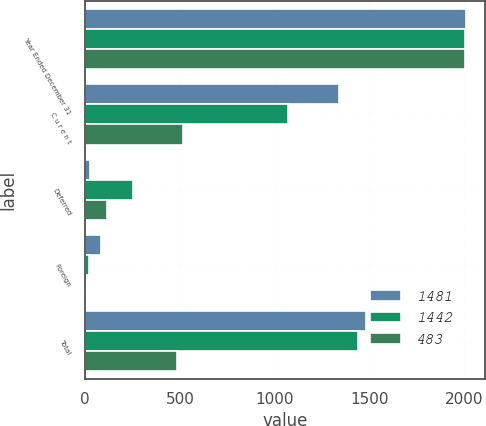<chart> <loc_0><loc_0><loc_500><loc_500><stacked_bar_chart><ecel><fcel>Year Ended December 31<fcel>C u r e n t<fcel>Deferred<fcel>Foreign<fcel>Total<nl><fcel>1481<fcel>2007<fcel>1340<fcel>27<fcel>85<fcel>1481<nl><fcel>1442<fcel>2006<fcel>1068<fcel>251<fcel>23<fcel>1442<nl><fcel>483<fcel>2005<fcel>517<fcel>117<fcel>5<fcel>483<nl></chart> 